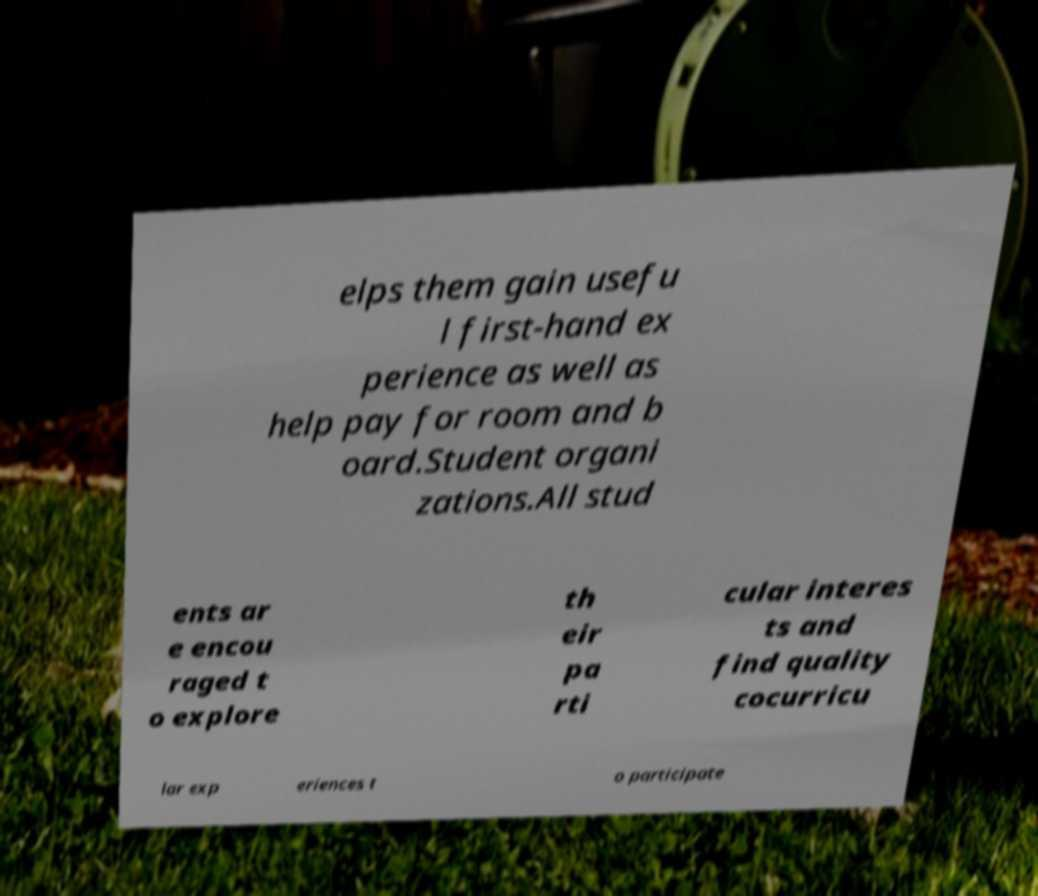Please identify and transcribe the text found in this image. elps them gain usefu l first-hand ex perience as well as help pay for room and b oard.Student organi zations.All stud ents ar e encou raged t o explore th eir pa rti cular interes ts and find quality cocurricu lar exp eriences t o participate 